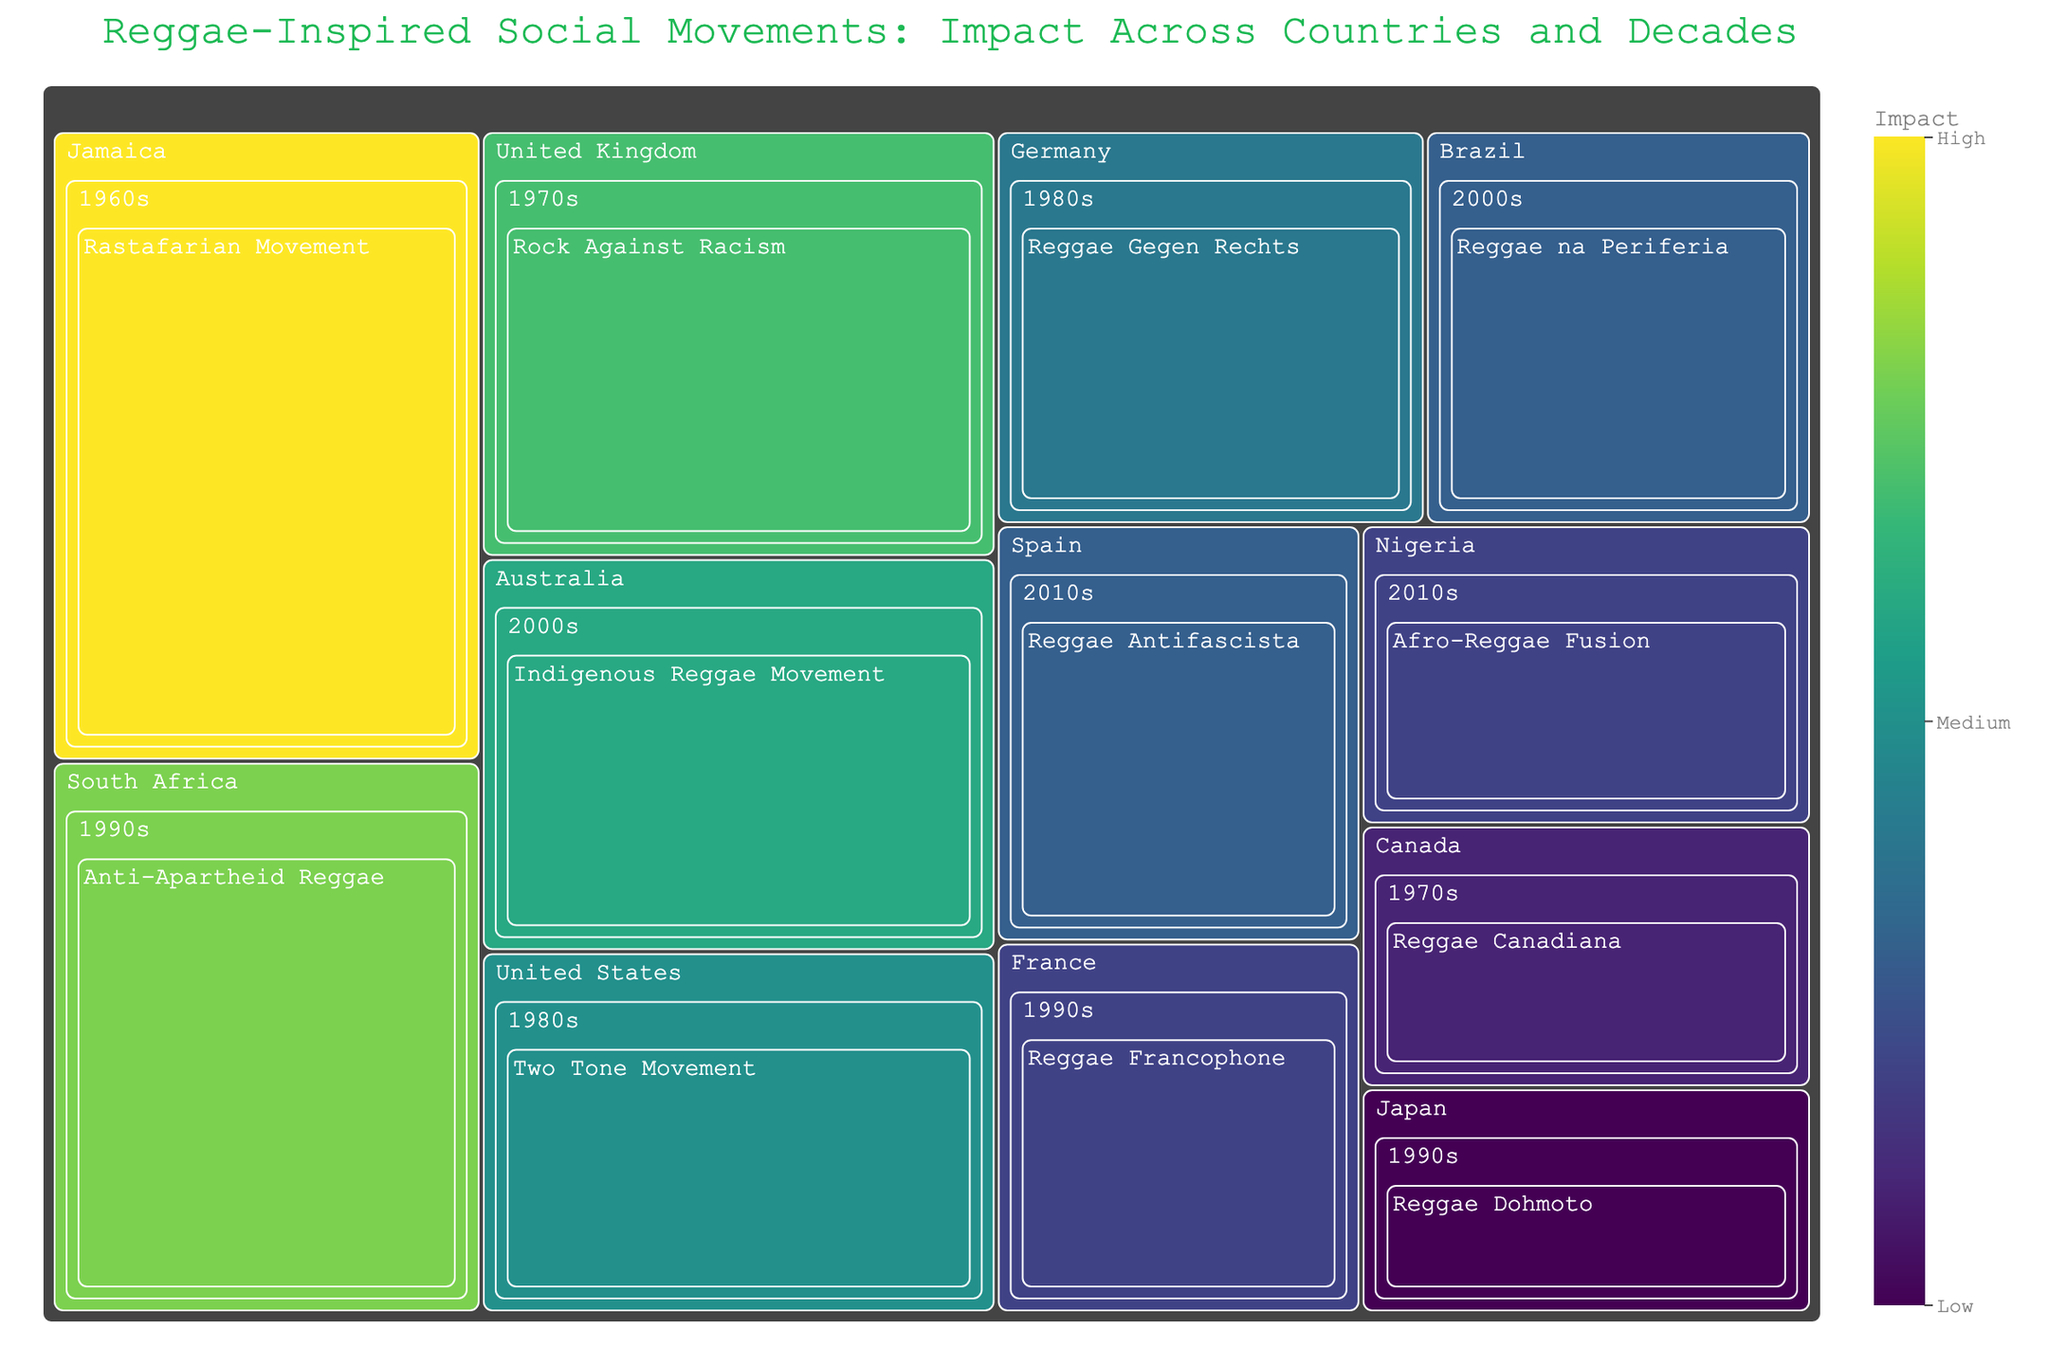What is the title of the treemap figure? The title of the figure is usually prominently displayed at the top. In this case, it directly mentions the theme of the figure.
Answer: Reggae-Inspired Social Movements: Impact Across Countries and Decades Which country has the highest impact movement? Identify the country with the movement that has the highest impact value by referring to the treemap color intensity and value labels.
Answer: Jamaica How many movements are represented in the 1990s? Count the number of distinct movement boxes under the 1990s decade section in the treemap.
Answer: Four Which decade saw the lowest impact in Brazil? Look for Brazil in the treemap and compare the impact values from different decades by observing the distinct boxes under each decade.
Answer: 2000s What is the impact of the "Rock Against Racism" movement in the United Kingdom during the 1970s? Find the "Rock Against Racism" movement within the United Kingdom section for the 1970s and note the impact value associated.
Answer: 65 Compare the impact of "Reggae na Periferia" in Brazil during the 2000s with "Indigenous Reggae Movement" in Australia during the same decade. Which one is higher? Look for both movements in the 2000s and compare their impact values side by side.
Answer: Indigenous Reggae Movement What is the average impact of movements in the 1980s? Identify the movements in the 1980s, sum their impact values, and then divide by the number of movements. The movements are "Two Tone Movement" (55) and "Reggae Gegen Rechts" (50).
Answer: (55 + 50) / 2 = 52.5 Which movement in the 2010s has a higher impact, "Afro-Reggae Fusion" in Nigeria or "Reggae Antifascista" in Spain? Compare the impact values of the two mentioned movements in the 2010s section.
Answer: Reggae Antifascista How does the impact of the "Anti-Apartheid Reggae" movement in South Africa during the 1990s compare to "Reggae Francophone" in France during the same decade? Analyze the impact values for both movements within the 1990s section.
Answer: Anti-Apartheid Reggae has a higher impact Which decade has the most diverse range of movements? Compare the number of different movement boxes under each decade in the treemap.
Answer: 1990s 